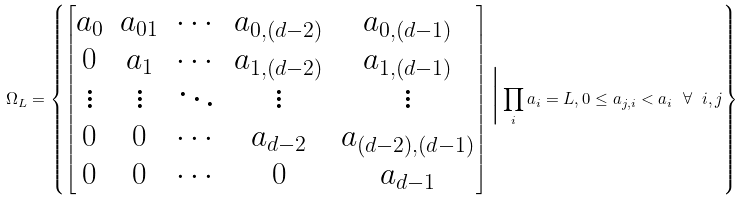<formula> <loc_0><loc_0><loc_500><loc_500>\Omega _ { L } = \left \{ \begin{bmatrix} a _ { 0 } & a _ { 0 1 } & \cdots & a _ { 0 , ( d - 2 ) } & a _ { 0 , ( d - 1 ) } \\ 0 & a _ { 1 } & \cdots & a _ { 1 , ( d - 2 ) } & a _ { 1 , ( d - 1 ) } \\ \vdots & \vdots & \ddots & \vdots & \vdots \\ 0 & 0 & \cdots & a _ { d - 2 } & a _ { ( d - 2 ) , ( d - 1 ) } \\ 0 & 0 & \cdots & 0 & a _ { d - 1 } \end{bmatrix} \Big | \prod _ { i } a _ { i } = L , 0 \leq a _ { j , i } < a _ { i } \ \forall \ i , j \right \}</formula> 